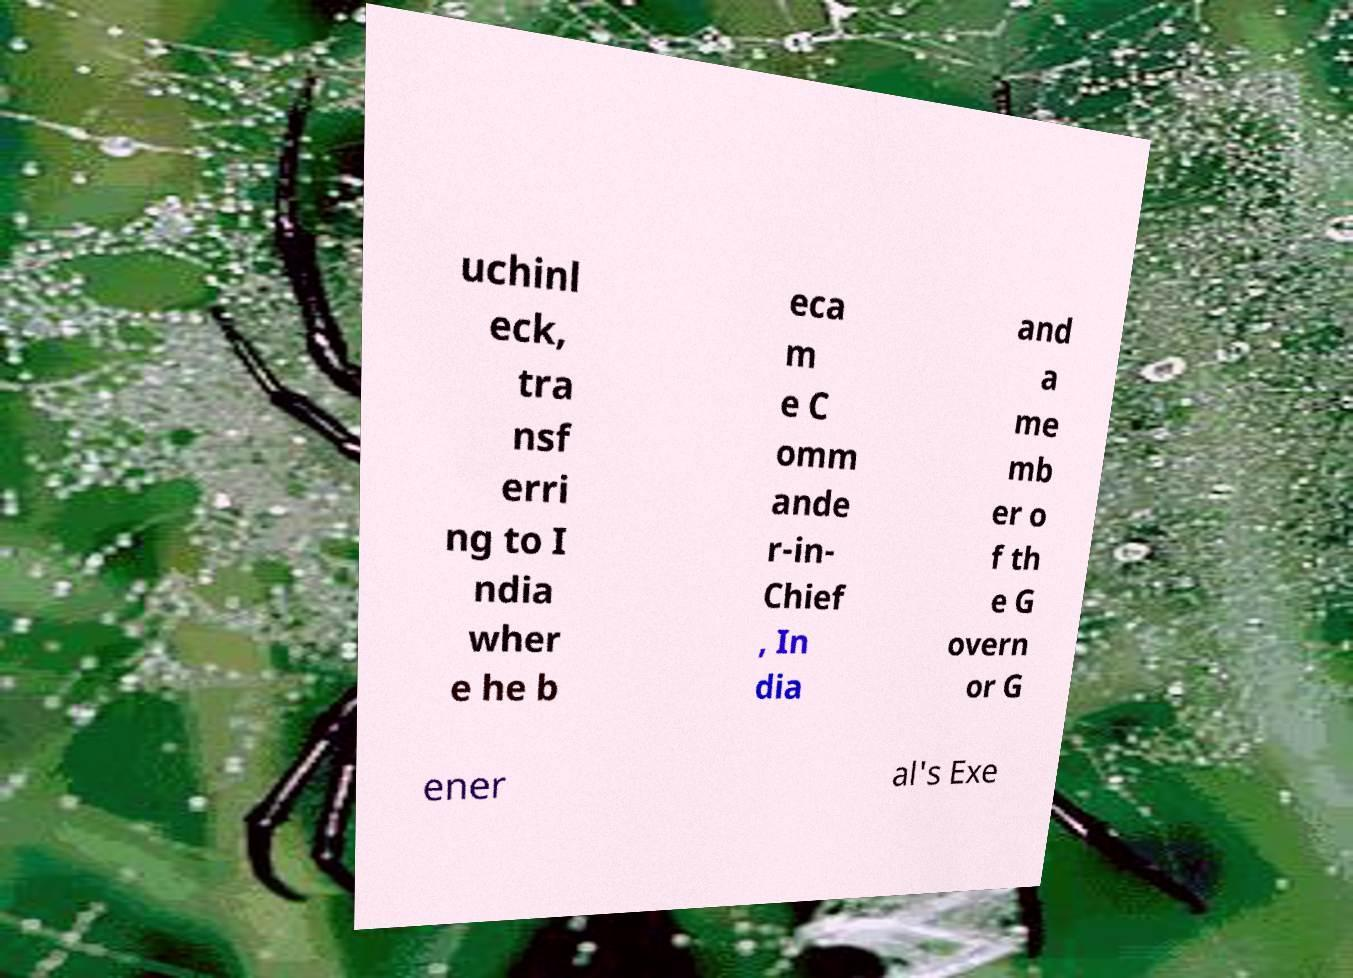Can you accurately transcribe the text from the provided image for me? uchinl eck, tra nsf erri ng to I ndia wher e he b eca m e C omm ande r-in- Chief , In dia and a me mb er o f th e G overn or G ener al's Exe 